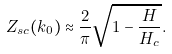<formula> <loc_0><loc_0><loc_500><loc_500>Z _ { s c } ( k _ { 0 } ) \approx \frac { 2 } { \pi } \sqrt { 1 - \frac { H } { H _ { c } } } .</formula> 